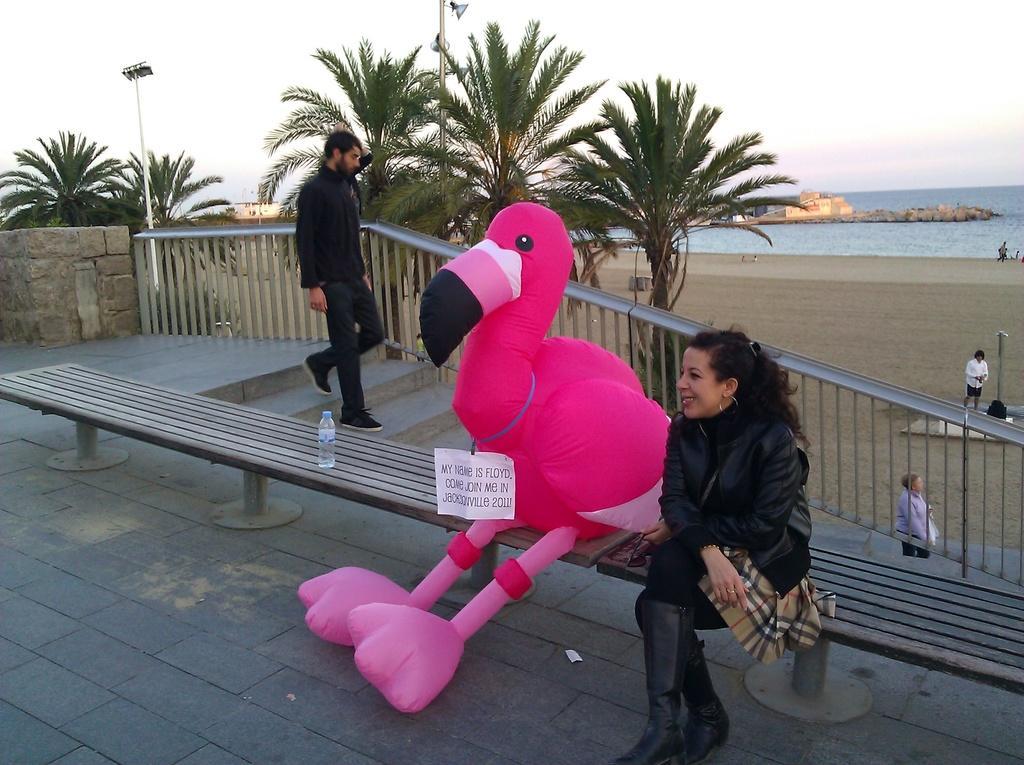Can you describe this image briefly? In the center of the image there is a soft toy and woman sitting on the bench. On the left side of the image we can see trees, persons, stairs and water bottle. In the background we can see persons, sand, water, building and sky. 